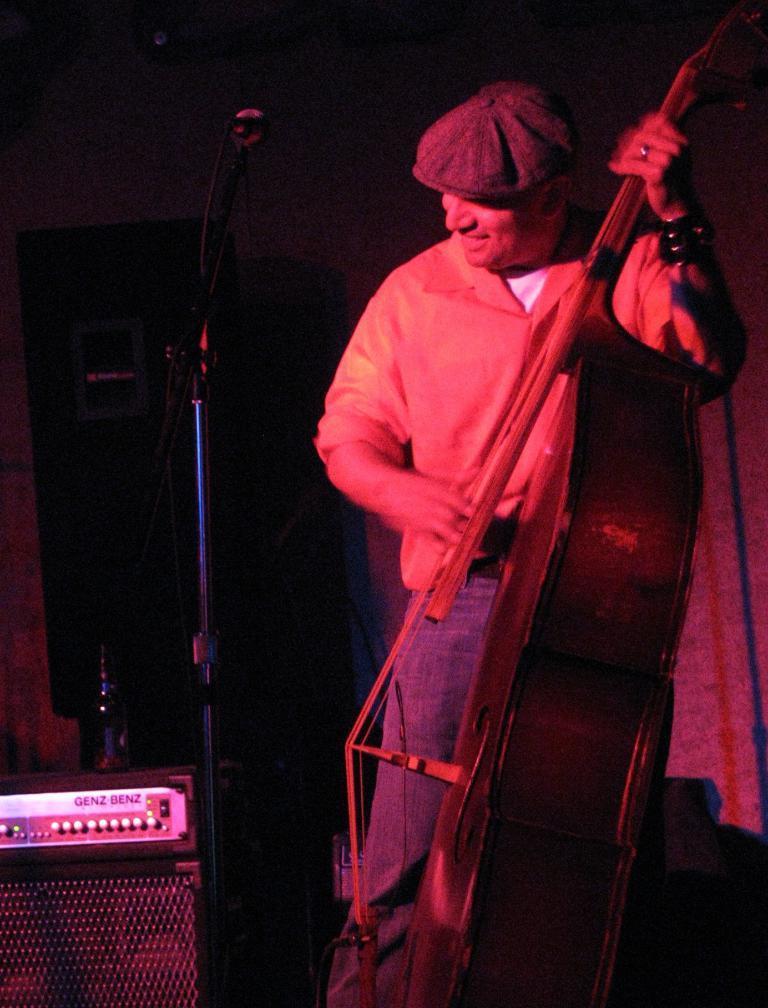In one or two sentences, can you explain what this image depicts? In this image I can see a man is standing and holding a musical instrument. I can also see he is wearing a cap. 